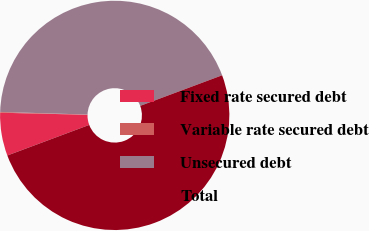Convert chart. <chart><loc_0><loc_0><loc_500><loc_500><pie_chart><fcel>Fixed rate secured debt<fcel>Variable rate secured debt<fcel>Unsecured debt<fcel>Total<nl><fcel>6.06%<fcel>0.11%<fcel>43.83%<fcel>50.0%<nl></chart> 